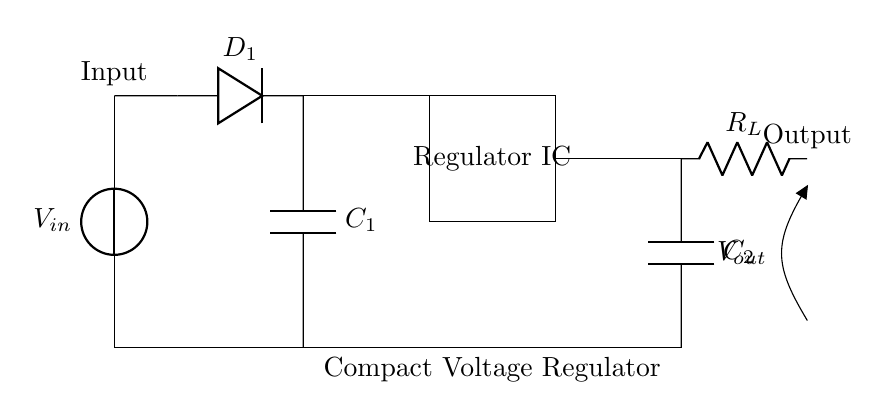What is the input source for this circuit? The circuit diagram indicates a voltage source labeled V_in at the left, which provides the input power.
Answer: Voltage source What type of component is D_1? The component D_1 in the diagram is a diode used for rectification of the voltage input.
Answer: Diode How many capacitors are present in the circuit? There are two capacitors shown in the circuit: C_1 and C_2.
Answer: Two What is the function of the regulator IC? The regulator IC is responsible for converting the varying input voltage into a stable output voltage suitable for the load.
Answer: Voltage regulation What does R_L represent in this circuit? R_L represents the load resistor, which is where the output voltage is delivered and utilized by the connected device.
Answer: Load resistor What is the location of the output voltage in the circuit? The output voltage, labeled V_out, can be found at the right side of the circuit after the load resistor R_L.
Answer: Right side Which component is responsible for stabilizing the input voltage? The voltage regulator IC is the component that stabilizes the input voltage to provide a steady output voltage to the load.
Answer: Regulator IC 